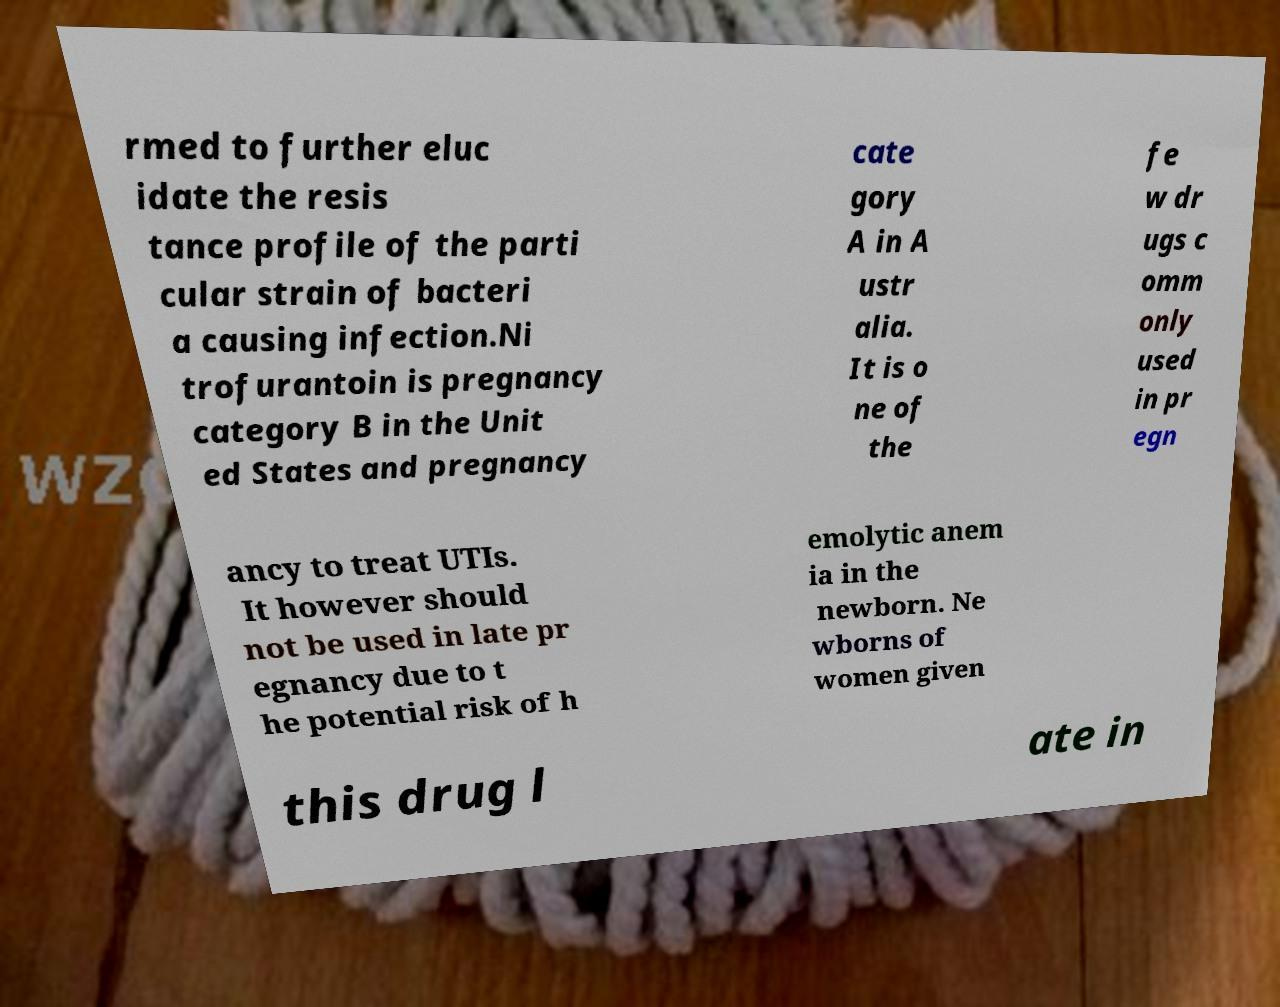Could you extract and type out the text from this image? rmed to further eluc idate the resis tance profile of the parti cular strain of bacteri a causing infection.Ni trofurantoin is pregnancy category B in the Unit ed States and pregnancy cate gory A in A ustr alia. It is o ne of the fe w dr ugs c omm only used in pr egn ancy to treat UTIs. It however should not be used in late pr egnancy due to t he potential risk of h emolytic anem ia in the newborn. Ne wborns of women given this drug l ate in 